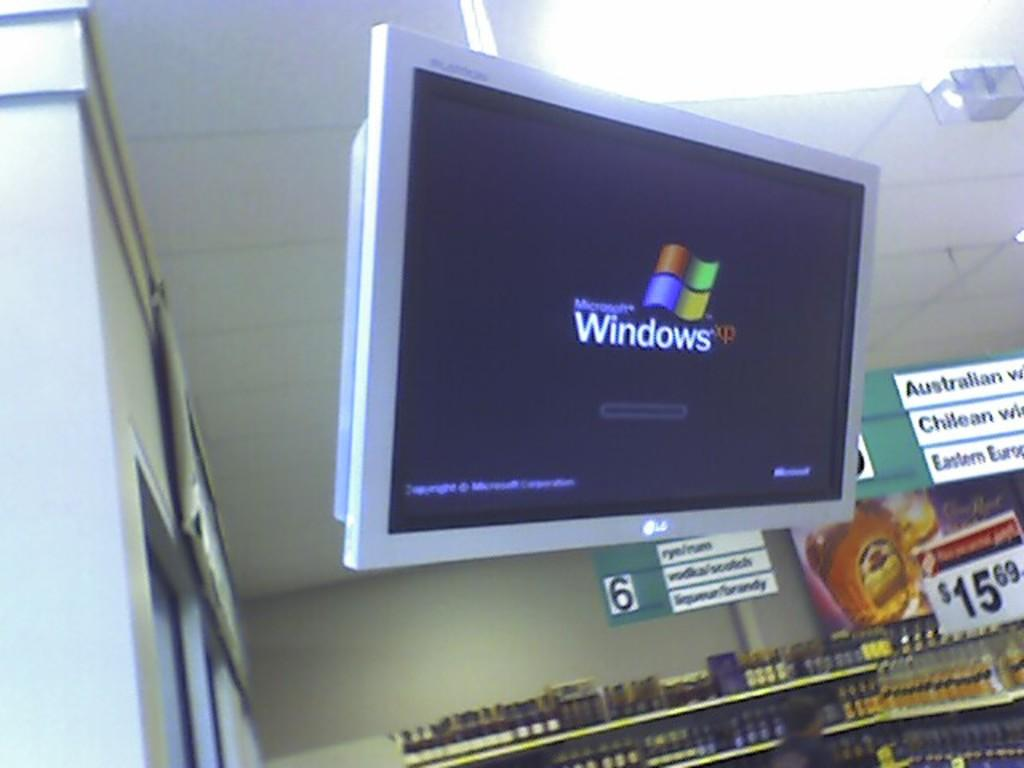<image>
Summarize the visual content of the image. In a store, a monitor hanging from the ceiling shows the windows xp logo. 